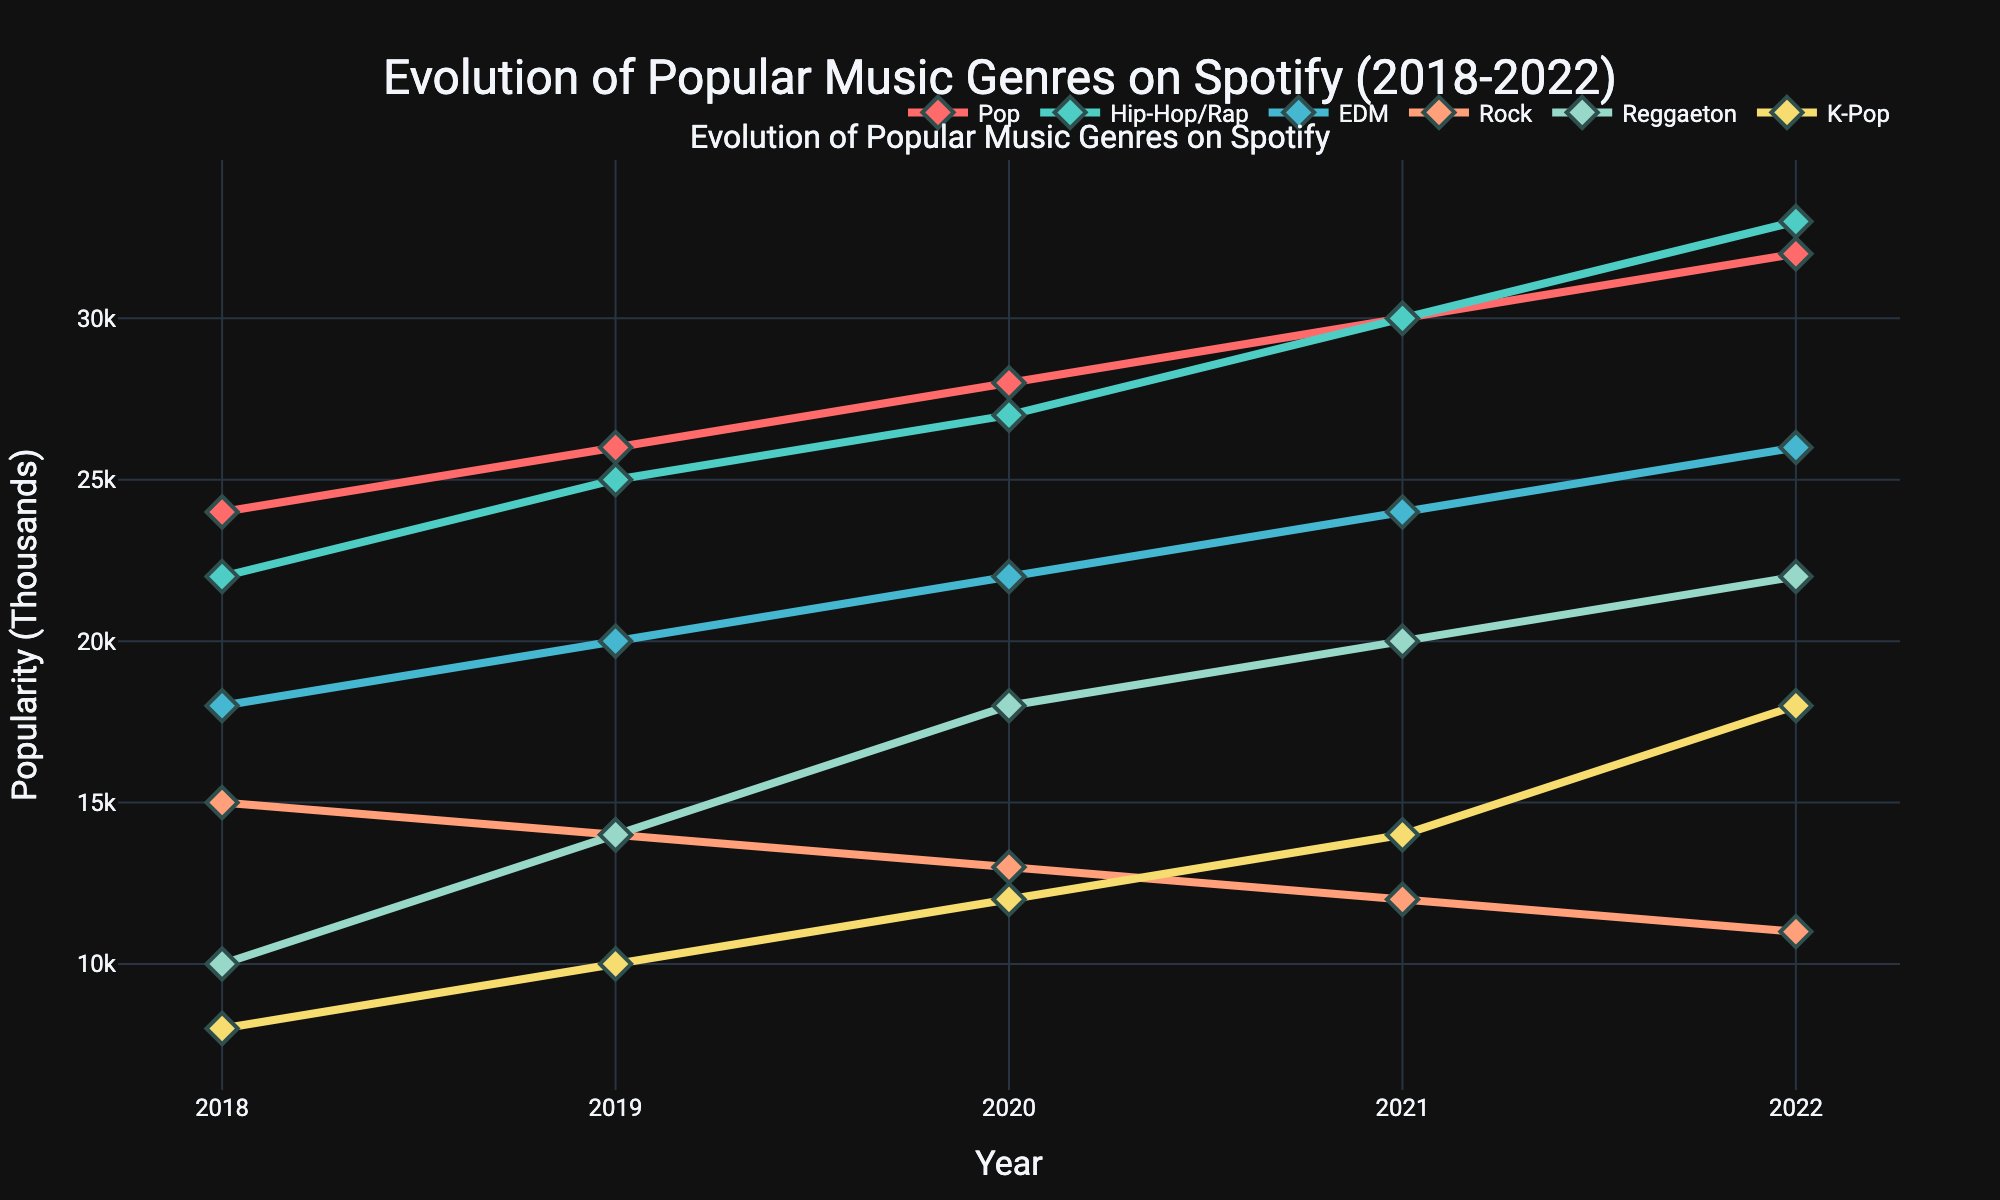What is the title of the plot? The title is usually placed at the top of the plot and gives an overview of what the plot represents. Here, the title is "Evolution of Popular Music Genres on Spotify (2018-2022)".
Answer: Evolution of Popular Music Genres on Spotify (2018-2022) Which music genre was the most popular in 2022? To find the most popular genre in 2022, check which line reaches the highest point on the y-axis for that year. The genre with the highest value is Hip-Hop/Rap.
Answer: Hip-Hop/Rap How many years' worth of data are displayed in the plot? The data points on the x-axis represent each year. The years displayed are 2018 to 2022, making it a total of 5 years.
Answer: 5 years Which music genre showed a consistent increase in popularity every year from 2018 to 2022? By inspecting each line, the genre that continuously moves upward without any decrease each year is Pop.
Answer: Pop Calculate the average popularity of EDM over the five years. To find the average, sum up the popularity values of EDM from 2018 to 2022, then divide by 5. The values are 18000, 20000, 22000, 24000, and 26000. Sum = 110000; Average = 110000 / 5 = 22000.
Answer: 22000 Which genres had their popularity decline in 2022 compared to their peak in previous years? By tracing back from 2022 to prior years for each genre, Rock shows a decline from its peak in 2018, and K-Pop shows a decline from its peak in 2020.
Answer: Rock, K-Pop Between 2018 and 2022, which genre had the highest increase in popularity? Calculate the difference between 2022 and 2018 values for each genre and find the maximum increase. Increases are Pop (8000), Hip-Hop/Rap (11000), EDM (8000), Rock (-4000), Reggaeton (12000), K-Pop (10000). The highest increase is in Reggaeton.
Answer: Reggaeton Which music genre had the lowest popularity in 2018? Compare the y-axis values for 2018 across all genres. The lowest value is for K-Pop.
Answer: K-Pop In which year did Hip-Hop/Rap surpass Pop in popularity? Inspect the plot for the first year where the line for Hip-Hop/Rap is above Pop. Hip-Hop/Rap surpasses Pop in 2019.
Answer: 2019 